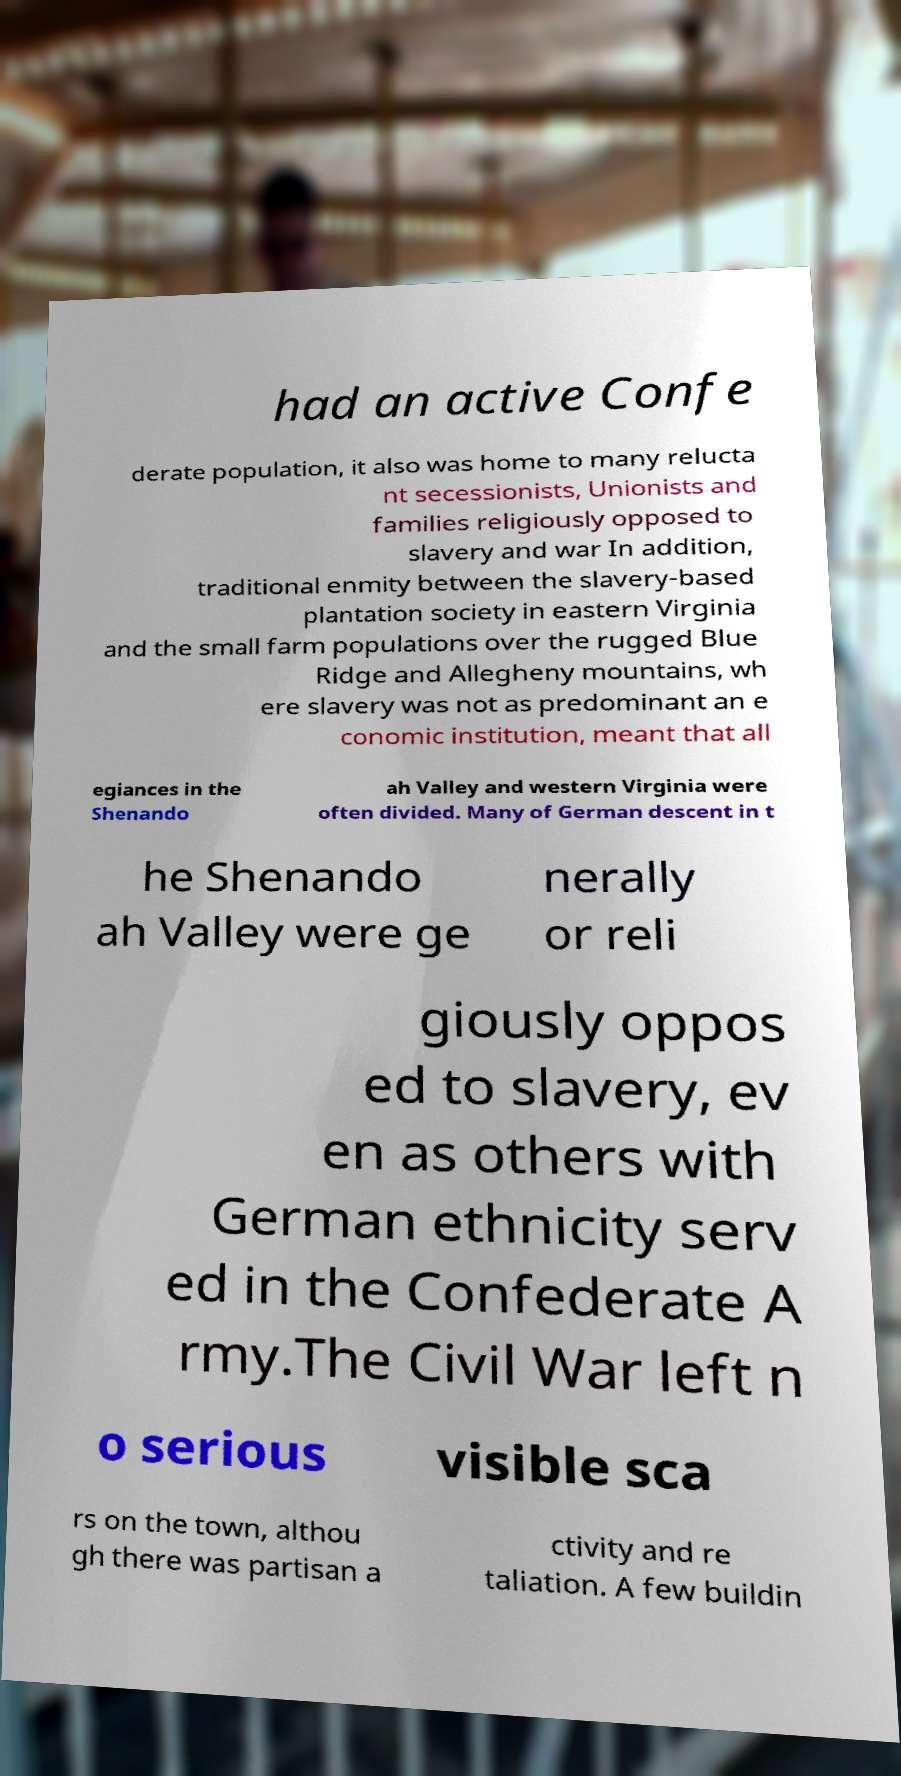For documentation purposes, I need the text within this image transcribed. Could you provide that? had an active Confe derate population, it also was home to many relucta nt secessionists, Unionists and families religiously opposed to slavery and war In addition, traditional enmity between the slavery-based plantation society in eastern Virginia and the small farm populations over the rugged Blue Ridge and Allegheny mountains, wh ere slavery was not as predominant an e conomic institution, meant that all egiances in the Shenando ah Valley and western Virginia were often divided. Many of German descent in t he Shenando ah Valley were ge nerally or reli giously oppos ed to slavery, ev en as others with German ethnicity serv ed in the Confederate A rmy.The Civil War left n o serious visible sca rs on the town, althou gh there was partisan a ctivity and re taliation. A few buildin 